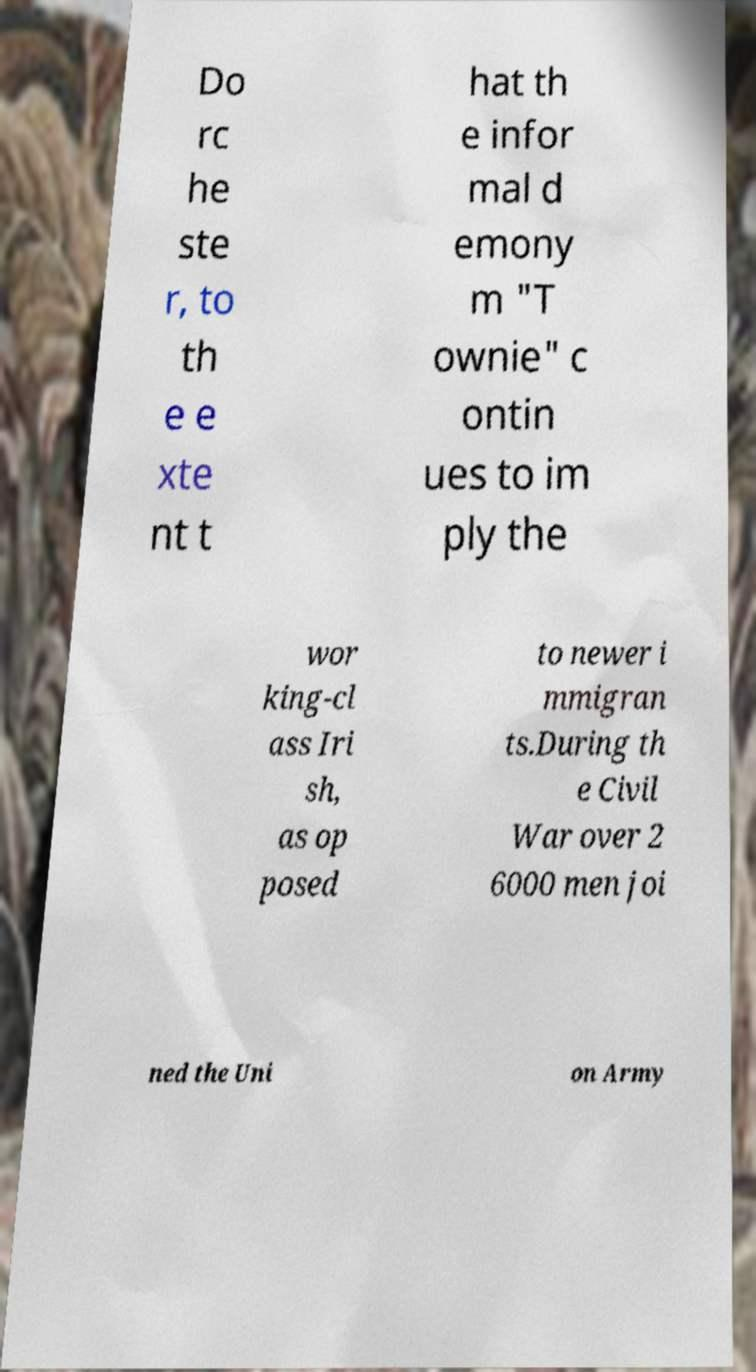Could you extract and type out the text from this image? Do rc he ste r, to th e e xte nt t hat th e infor mal d emony m "T ownie" c ontin ues to im ply the wor king-cl ass Iri sh, as op posed to newer i mmigran ts.During th e Civil War over 2 6000 men joi ned the Uni on Army 